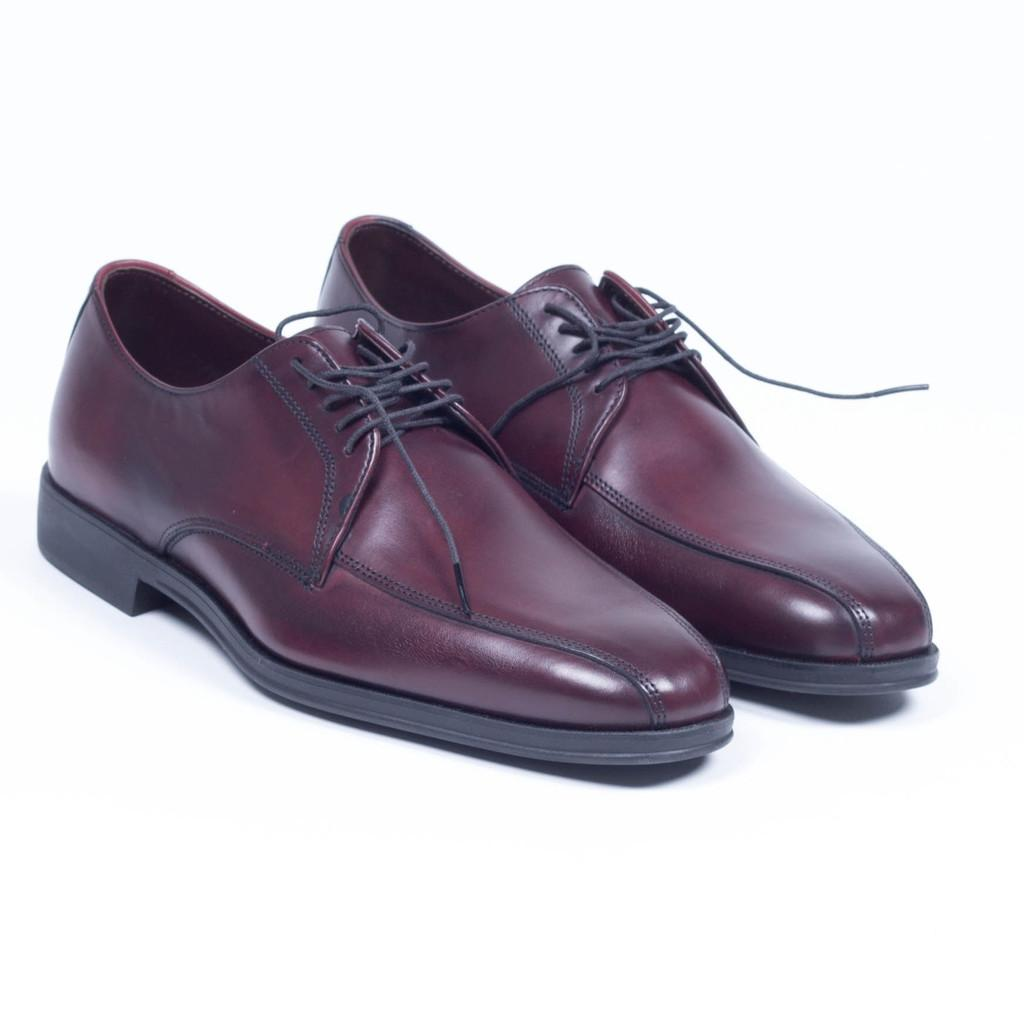What type of footwear is visible in the image? There are leather shoes in the image. What color is the background of the image? The background of the image is white. Where is the apple located in the image? There is no apple present in the image. What type of answer can be seen written on the shoes? There is no answer written on the shoes; they are simply leather footwear. 